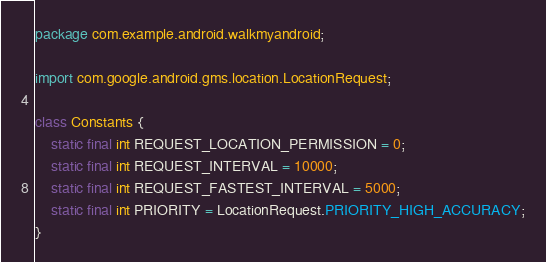<code> <loc_0><loc_0><loc_500><loc_500><_Java_>package com.example.android.walkmyandroid;

import com.google.android.gms.location.LocationRequest;

class Constants {
    static final int REQUEST_LOCATION_PERMISSION = 0;
    static final int REQUEST_INTERVAL = 10000;
    static final int REQUEST_FASTEST_INTERVAL = 5000;
    static final int PRIORITY = LocationRequest.PRIORITY_HIGH_ACCURACY;
}
</code> 